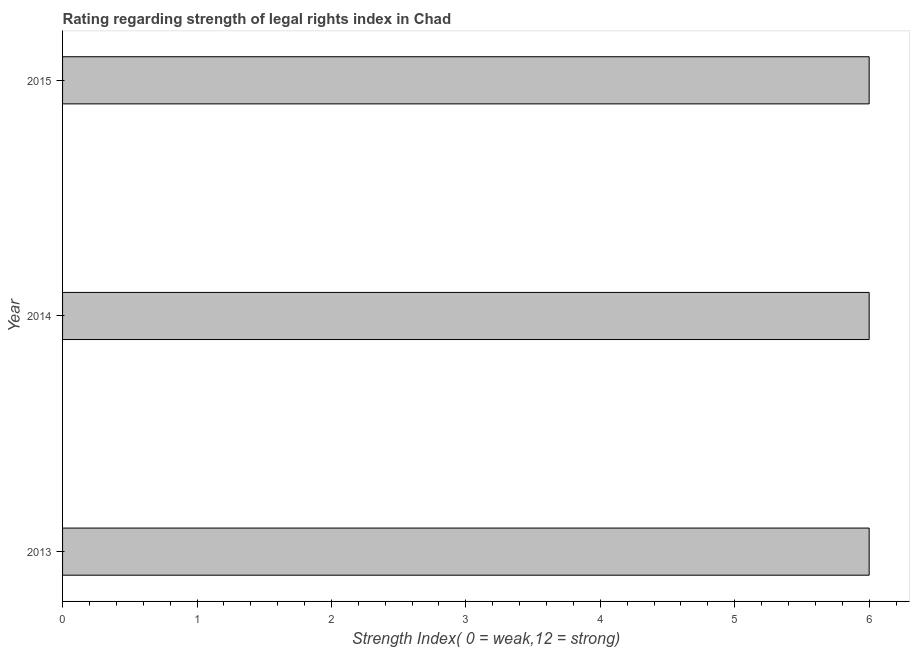Does the graph contain any zero values?
Make the answer very short. No. What is the title of the graph?
Give a very brief answer. Rating regarding strength of legal rights index in Chad. What is the label or title of the X-axis?
Provide a short and direct response. Strength Index( 0 = weak,12 = strong). In which year was the strength of legal rights index minimum?
Offer a very short reply. 2013. What is the sum of the strength of legal rights index?
Give a very brief answer. 18. What is the difference between the strength of legal rights index in 2014 and 2015?
Your answer should be very brief. 0. What is the average strength of legal rights index per year?
Keep it short and to the point. 6. Do a majority of the years between 2015 and 2013 (inclusive) have strength of legal rights index greater than 3.6 ?
Offer a terse response. Yes. What is the ratio of the strength of legal rights index in 2014 to that in 2015?
Your answer should be compact. 1. Is the strength of legal rights index in 2014 less than that in 2015?
Your response must be concise. No. Is the difference between the strength of legal rights index in 2013 and 2014 greater than the difference between any two years?
Your response must be concise. Yes. What is the difference between the highest and the second highest strength of legal rights index?
Ensure brevity in your answer.  0. How many bars are there?
Offer a terse response. 3. What is the difference between two consecutive major ticks on the X-axis?
Your response must be concise. 1. What is the Strength Index( 0 = weak,12 = strong) in 2014?
Your answer should be compact. 6. What is the difference between the Strength Index( 0 = weak,12 = strong) in 2013 and 2014?
Give a very brief answer. 0. 